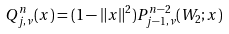Convert formula to latex. <formula><loc_0><loc_0><loc_500><loc_500>Q _ { j , \nu } ^ { n } ( x ) = ( 1 - \| x \| ^ { 2 } ) P _ { j - 1 , \nu } ^ { n - 2 } ( W _ { 2 } ; x )</formula> 